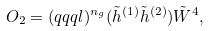Convert formula to latex. <formula><loc_0><loc_0><loc_500><loc_500>O _ { 2 } = ( q q q l ) ^ { n _ { g } } ( \tilde { h } ^ { ( 1 ) } \tilde { h } ^ { ( 2 ) } ) \tilde { W } ^ { 4 } ,</formula> 